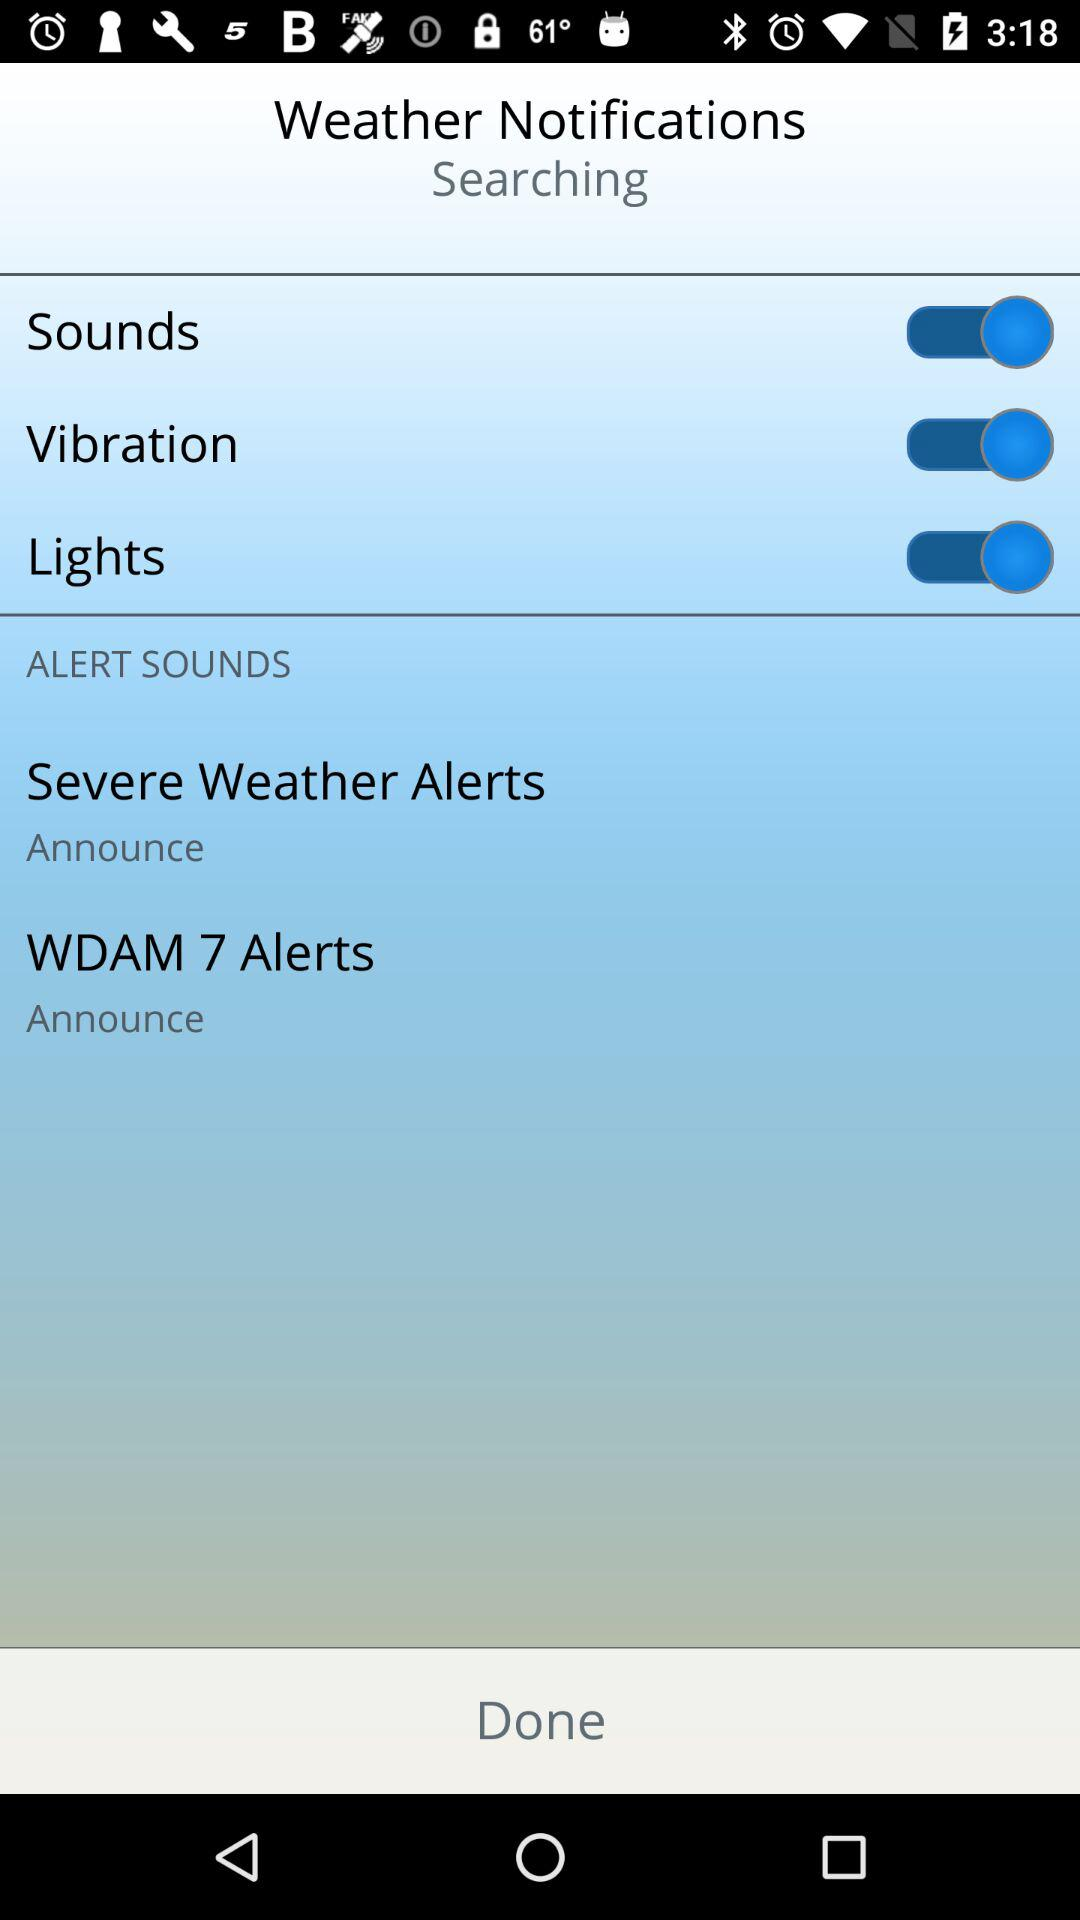How to search for weather notifications?
When the provided information is insufficient, respond with <no answer>. <no answer> 